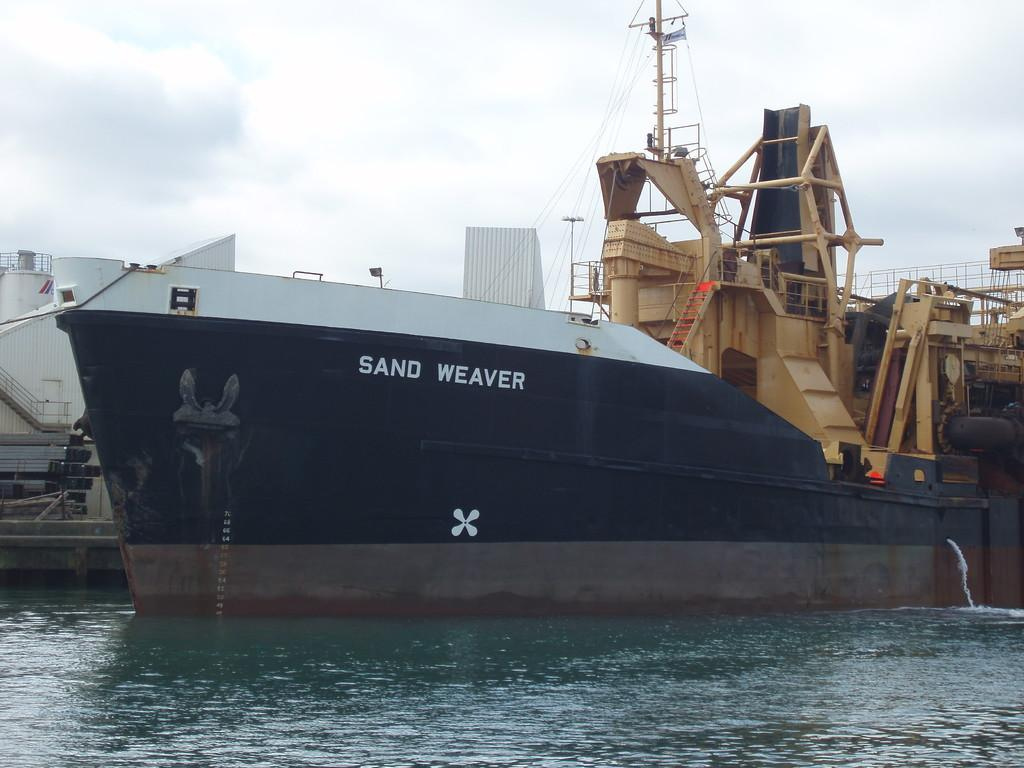<image>
Render a clear and concise summary of the photo. White and black ship which is named Sand Weaver. 